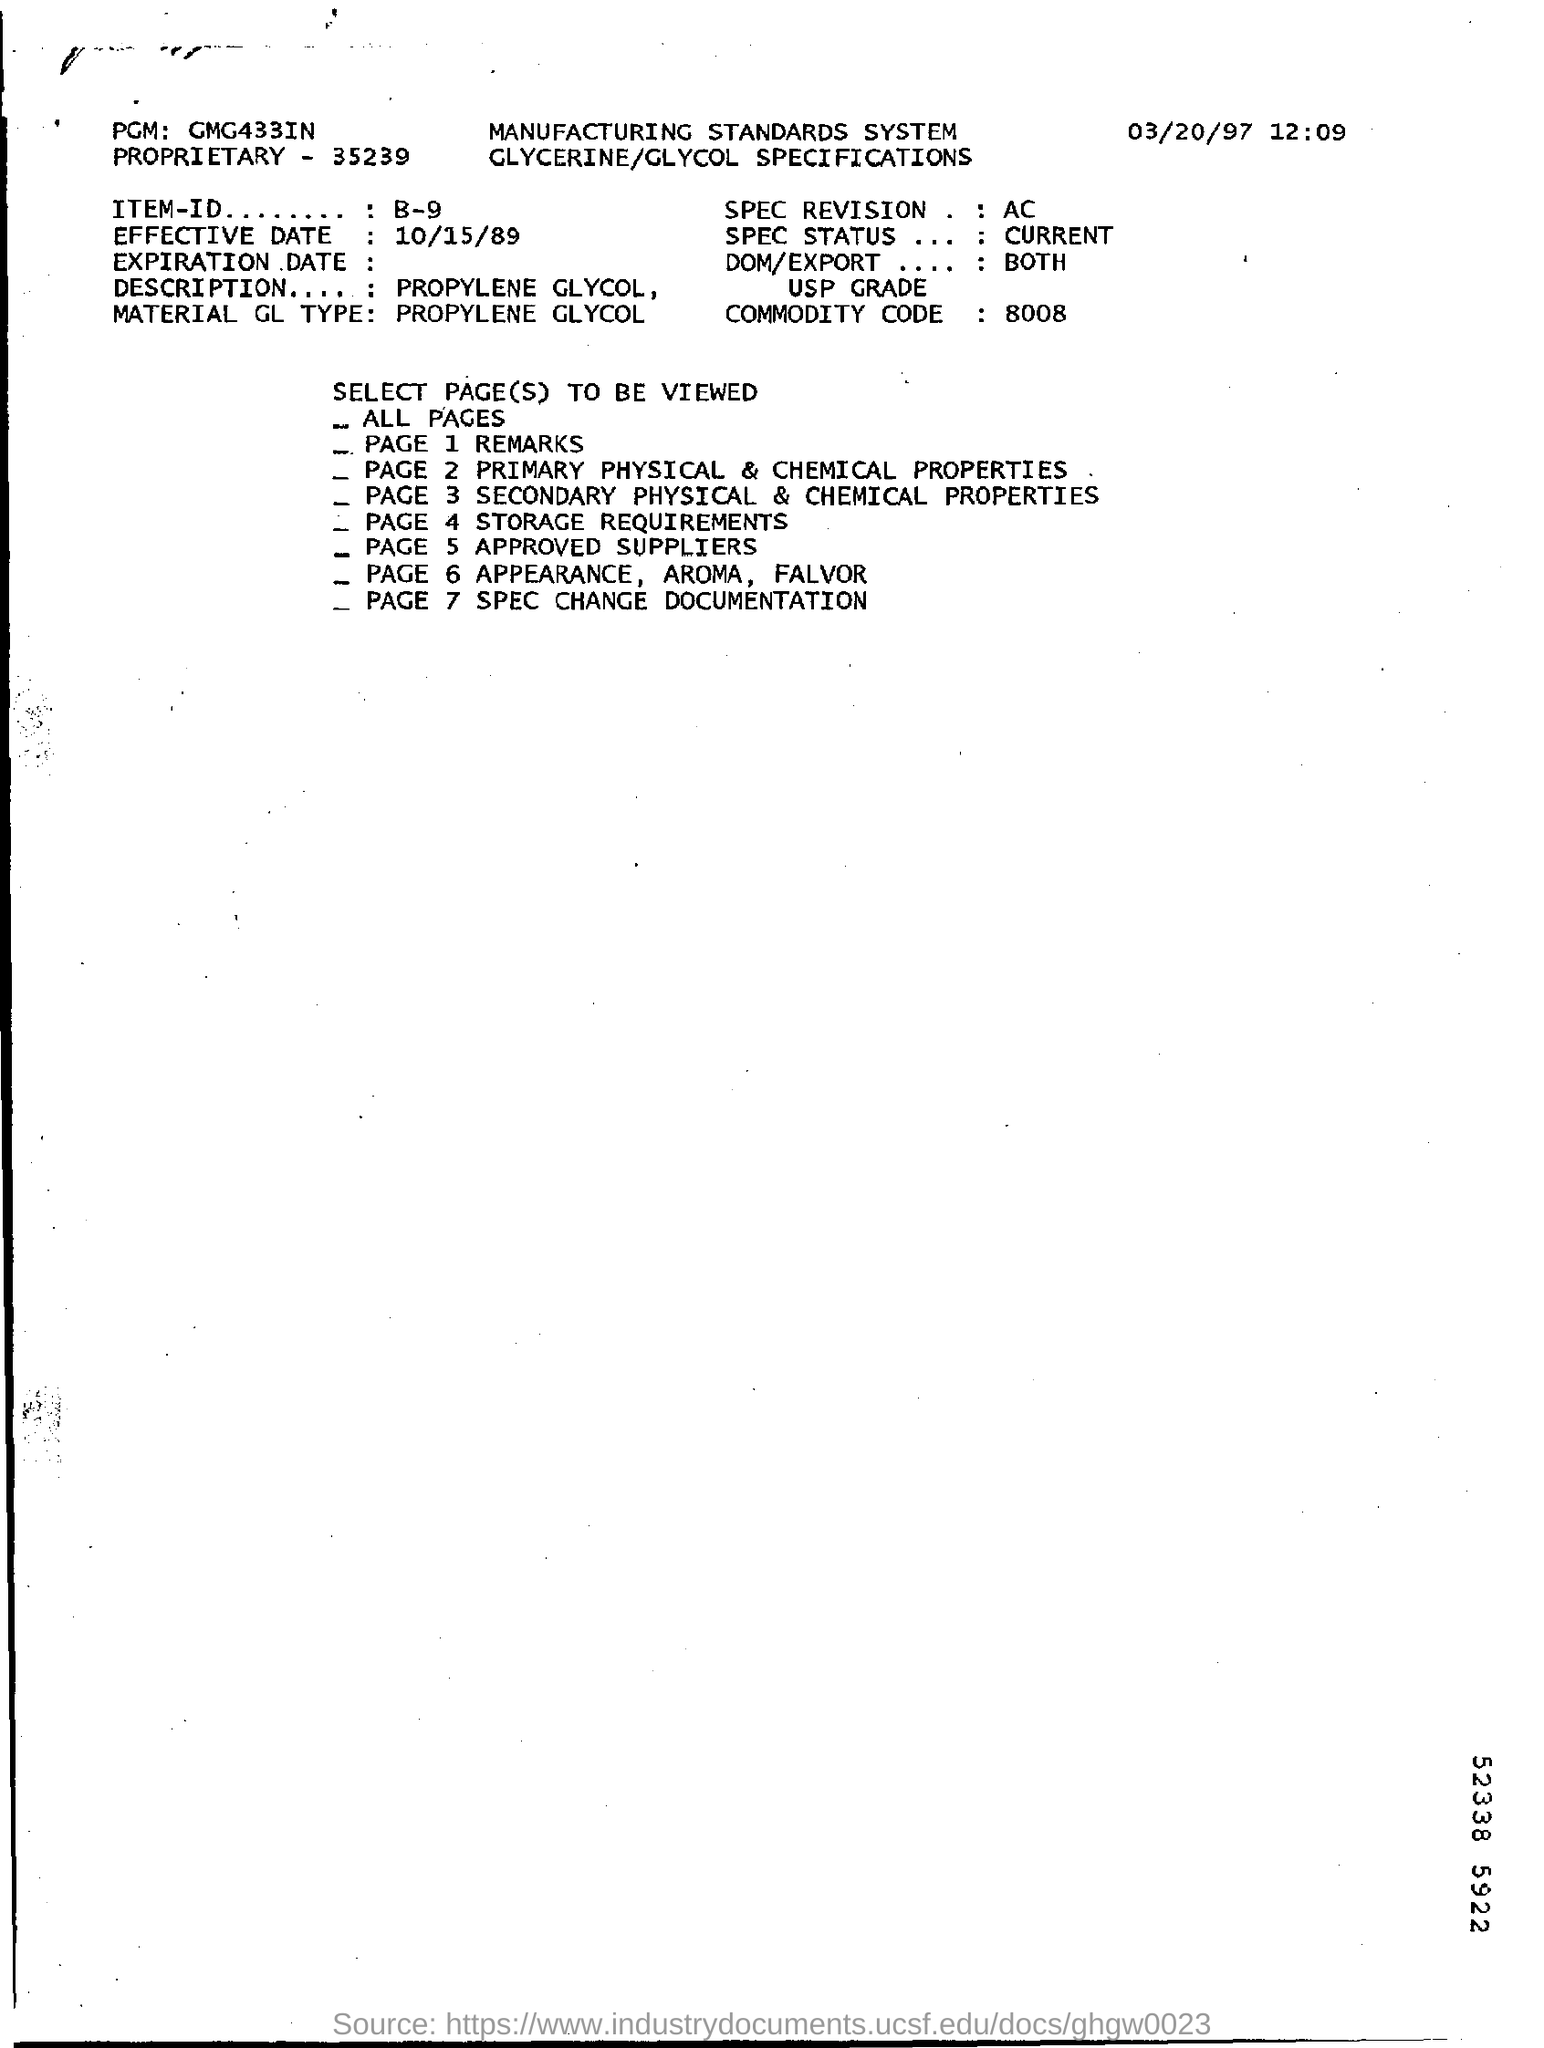What is the Commodity Code as mentioned in the document?
Ensure brevity in your answer.  8008. What is the Material GL Type?
Give a very brief answer. PROPYLENE GLYCOL. What is the Effective Date mentioned in this document?
Offer a terse response. 10/15/89. What is the ITEM-ID given?
Offer a very short reply. B-9. Which topic is discussed in PAGE 5 of this document?
Ensure brevity in your answer.  APPROVED SUPPLIERS. 